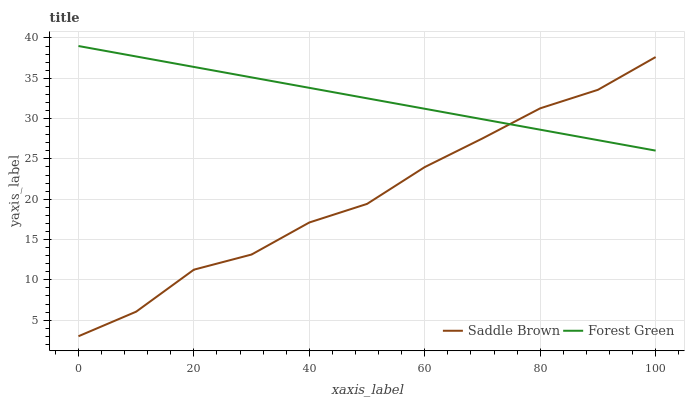Does Saddle Brown have the minimum area under the curve?
Answer yes or no. Yes. Does Forest Green have the maximum area under the curve?
Answer yes or no. Yes. Does Saddle Brown have the maximum area under the curve?
Answer yes or no. No. Is Forest Green the smoothest?
Answer yes or no. Yes. Is Saddle Brown the roughest?
Answer yes or no. Yes. Is Saddle Brown the smoothest?
Answer yes or no. No. Does Saddle Brown have the lowest value?
Answer yes or no. Yes. Does Forest Green have the highest value?
Answer yes or no. Yes. Does Saddle Brown have the highest value?
Answer yes or no. No. Does Forest Green intersect Saddle Brown?
Answer yes or no. Yes. Is Forest Green less than Saddle Brown?
Answer yes or no. No. Is Forest Green greater than Saddle Brown?
Answer yes or no. No. 